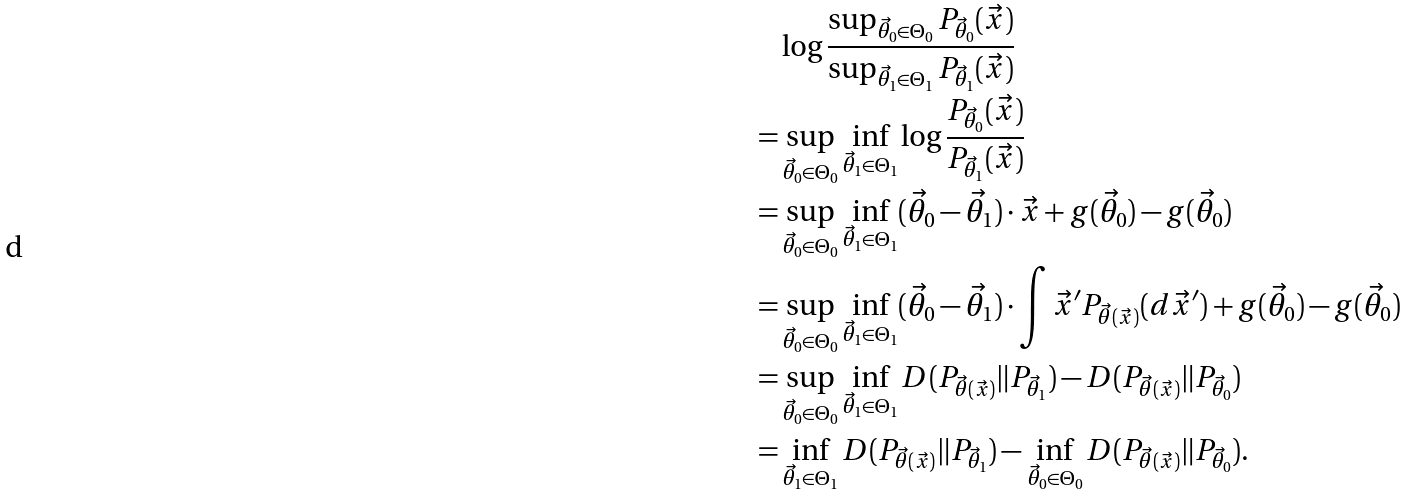Convert formula to latex. <formula><loc_0><loc_0><loc_500><loc_500>& \log \frac { \sup _ { \vec { \theta } _ { 0 } \in \Theta _ { 0 } } P _ { \vec { \theta } _ { 0 } } ( \vec { x } ) } { \sup _ { \vec { \theta } _ { 1 } \in \Theta _ { 1 } } P _ { \vec { \theta } _ { 1 } } ( \vec { x } ) } \\ = & \sup _ { \vec { \theta } _ { 0 } \in \Theta _ { 0 } } \inf _ { \vec { \theta } _ { 1 } \in \Theta _ { 1 } } \log \frac { P _ { \vec { \theta } _ { 0 } } ( \vec { x } ) } { P _ { \vec { \theta } _ { 1 } } ( \vec { x } ) } \\ = & \sup _ { \vec { \theta } _ { 0 } \in \Theta _ { 0 } } \inf _ { \vec { \theta } _ { 1 } \in \Theta _ { 1 } } ( \vec { \theta } _ { 0 } - \vec { \theta } _ { 1 } ) \cdot \vec { x } + g ( \vec { \theta } _ { 0 } ) - g ( \vec { \theta } _ { 0 } ) \\ = & \sup _ { \vec { \theta } _ { 0 } \in \Theta _ { 0 } } \inf _ { \vec { \theta } _ { 1 } \in \Theta _ { 1 } } ( \vec { \theta } _ { 0 } - \vec { \theta } _ { 1 } ) \cdot \int \vec { x } ^ { \prime } P _ { \vec { \theta } ( \vec { x } ) } ( d \vec { x } ^ { \prime } ) + g ( \vec { \theta } _ { 0 } ) - g ( \vec { \theta } _ { 0 } ) \\ = & \sup _ { \vec { \theta } _ { 0 } \in \Theta _ { 0 } } \inf _ { \vec { \theta } _ { 1 } \in \Theta _ { 1 } } D ( P _ { \vec { \theta } ( \vec { x } ) } \| P _ { \vec { \theta } _ { 1 } } ) - D ( P _ { \vec { \theta } ( \vec { x } ) } \| P _ { \vec { \theta } _ { 0 } } ) \\ = & \inf _ { \vec { \theta } _ { 1 } \in \Theta _ { 1 } } D ( P _ { \vec { \theta } ( \vec { x } ) } \| P _ { \vec { \theta } _ { 1 } } ) - \inf _ { \vec { \theta } _ { 0 } \in \Theta _ { 0 } } D ( P _ { \vec { \theta } ( \vec { x } ) } \| P _ { \vec { \theta } _ { 0 } } ) .</formula> 